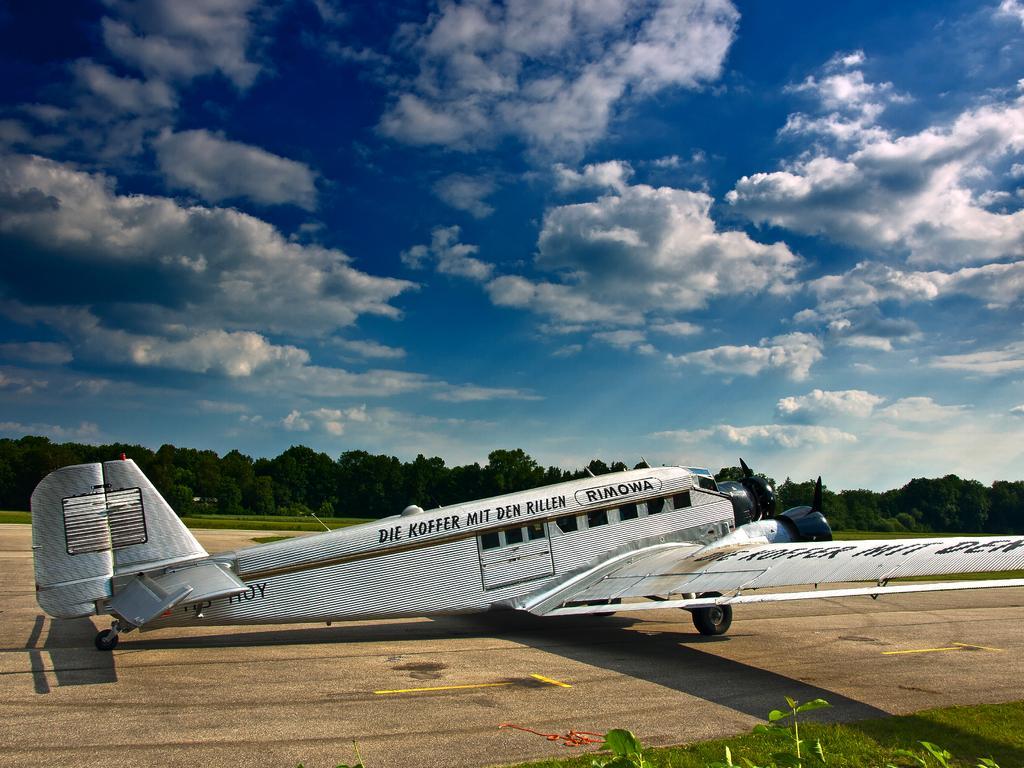In one or two sentences, can you explain what this image depicts? In this picture we can see an airplane on the ground, trees and in the background we can see the sky with clouds. 